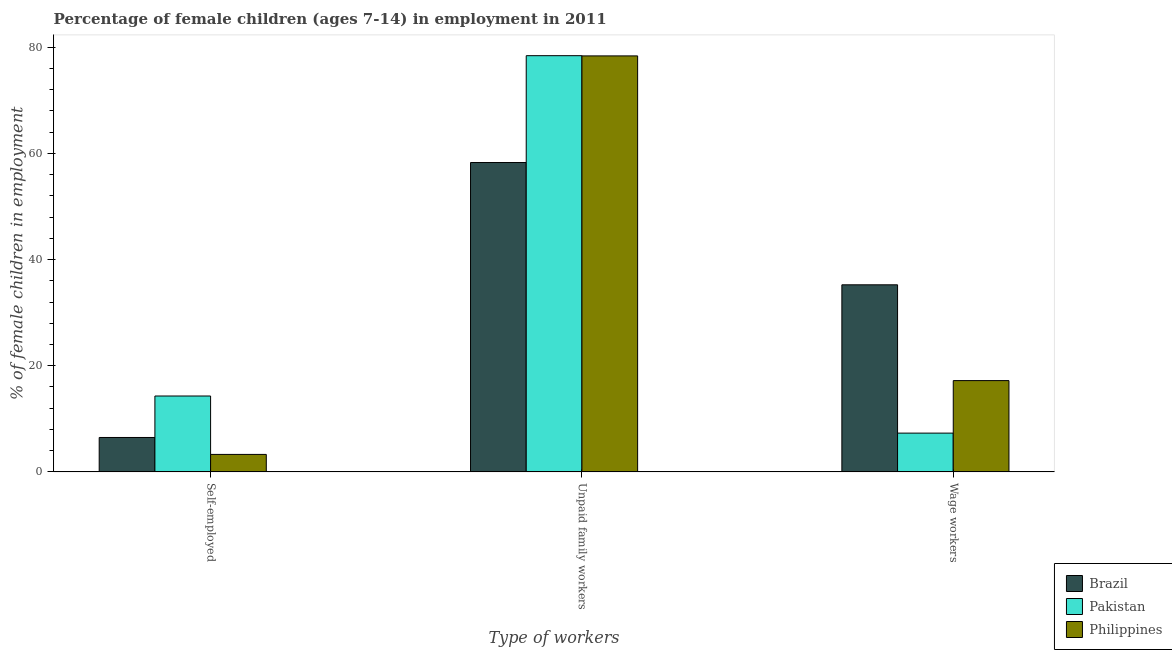How many different coloured bars are there?
Keep it short and to the point. 3. Are the number of bars per tick equal to the number of legend labels?
Your answer should be very brief. Yes. How many bars are there on the 3rd tick from the left?
Your response must be concise. 3. How many bars are there on the 1st tick from the right?
Offer a very short reply. 3. What is the label of the 2nd group of bars from the left?
Your response must be concise. Unpaid family workers. What is the percentage of children employed as wage workers in Brazil?
Keep it short and to the point. 35.24. Across all countries, what is the maximum percentage of children employed as wage workers?
Provide a succinct answer. 35.24. Across all countries, what is the minimum percentage of children employed as unpaid family workers?
Give a very brief answer. 58.27. What is the total percentage of self employed children in the graph?
Your response must be concise. 24.09. What is the difference between the percentage of children employed as unpaid family workers in Philippines and that in Pakistan?
Provide a short and direct response. -0.04. What is the difference between the percentage of self employed children in Pakistan and the percentage of children employed as wage workers in Brazil?
Your response must be concise. -20.94. What is the average percentage of children employed as unpaid family workers per country?
Make the answer very short. 71.67. What is the difference between the percentage of self employed children and percentage of children employed as unpaid family workers in Pakistan?
Offer a very short reply. -64.09. What is the ratio of the percentage of children employed as unpaid family workers in Pakistan to that in Philippines?
Your response must be concise. 1. Is the percentage of self employed children in Philippines less than that in Pakistan?
Ensure brevity in your answer.  Yes. Is the difference between the percentage of self employed children in Pakistan and Brazil greater than the difference between the percentage of children employed as wage workers in Pakistan and Brazil?
Your answer should be very brief. Yes. What is the difference between the highest and the second highest percentage of children employed as unpaid family workers?
Offer a very short reply. 0.04. What is the difference between the highest and the lowest percentage of children employed as unpaid family workers?
Provide a short and direct response. 20.12. Is the sum of the percentage of children employed as wage workers in Pakistan and Brazil greater than the maximum percentage of children employed as unpaid family workers across all countries?
Give a very brief answer. No. What does the 3rd bar from the left in Wage workers represents?
Your answer should be very brief. Philippines. Is it the case that in every country, the sum of the percentage of self employed children and percentage of children employed as unpaid family workers is greater than the percentage of children employed as wage workers?
Keep it short and to the point. Yes. What is the difference between two consecutive major ticks on the Y-axis?
Offer a very short reply. 20. Does the graph contain any zero values?
Ensure brevity in your answer.  No. Does the graph contain grids?
Give a very brief answer. No. Where does the legend appear in the graph?
Your answer should be very brief. Bottom right. How many legend labels are there?
Your response must be concise. 3. How are the legend labels stacked?
Your response must be concise. Vertical. What is the title of the graph?
Your answer should be compact. Percentage of female children (ages 7-14) in employment in 2011. Does "Lesotho" appear as one of the legend labels in the graph?
Offer a very short reply. No. What is the label or title of the X-axis?
Make the answer very short. Type of workers. What is the label or title of the Y-axis?
Offer a very short reply. % of female children in employment. What is the % of female children in employment of Brazil in Self-employed?
Your answer should be very brief. 6.49. What is the % of female children in employment of Philippines in Self-employed?
Your answer should be compact. 3.3. What is the % of female children in employment of Brazil in Unpaid family workers?
Offer a very short reply. 58.27. What is the % of female children in employment in Pakistan in Unpaid family workers?
Your answer should be very brief. 78.39. What is the % of female children in employment in Philippines in Unpaid family workers?
Your answer should be compact. 78.35. What is the % of female children in employment of Brazil in Wage workers?
Offer a very short reply. 35.24. What is the % of female children in employment in Pakistan in Wage workers?
Ensure brevity in your answer.  7.31. Across all Type of workers, what is the maximum % of female children in employment in Brazil?
Keep it short and to the point. 58.27. Across all Type of workers, what is the maximum % of female children in employment of Pakistan?
Offer a very short reply. 78.39. Across all Type of workers, what is the maximum % of female children in employment of Philippines?
Provide a succinct answer. 78.35. Across all Type of workers, what is the minimum % of female children in employment in Brazil?
Make the answer very short. 6.49. Across all Type of workers, what is the minimum % of female children in employment of Pakistan?
Provide a succinct answer. 7.31. Across all Type of workers, what is the minimum % of female children in employment in Philippines?
Provide a succinct answer. 3.3. What is the total % of female children in employment in Philippines in the graph?
Your answer should be very brief. 98.85. What is the difference between the % of female children in employment in Brazil in Self-employed and that in Unpaid family workers?
Your response must be concise. -51.78. What is the difference between the % of female children in employment of Pakistan in Self-employed and that in Unpaid family workers?
Your answer should be very brief. -64.09. What is the difference between the % of female children in employment in Philippines in Self-employed and that in Unpaid family workers?
Make the answer very short. -75.05. What is the difference between the % of female children in employment of Brazil in Self-employed and that in Wage workers?
Provide a short and direct response. -28.75. What is the difference between the % of female children in employment of Pakistan in Self-employed and that in Wage workers?
Give a very brief answer. 6.99. What is the difference between the % of female children in employment in Philippines in Self-employed and that in Wage workers?
Ensure brevity in your answer.  -13.9. What is the difference between the % of female children in employment of Brazil in Unpaid family workers and that in Wage workers?
Provide a succinct answer. 23.03. What is the difference between the % of female children in employment in Pakistan in Unpaid family workers and that in Wage workers?
Provide a succinct answer. 71.08. What is the difference between the % of female children in employment in Philippines in Unpaid family workers and that in Wage workers?
Your response must be concise. 61.15. What is the difference between the % of female children in employment of Brazil in Self-employed and the % of female children in employment of Pakistan in Unpaid family workers?
Keep it short and to the point. -71.9. What is the difference between the % of female children in employment in Brazil in Self-employed and the % of female children in employment in Philippines in Unpaid family workers?
Keep it short and to the point. -71.86. What is the difference between the % of female children in employment in Pakistan in Self-employed and the % of female children in employment in Philippines in Unpaid family workers?
Keep it short and to the point. -64.05. What is the difference between the % of female children in employment of Brazil in Self-employed and the % of female children in employment of Pakistan in Wage workers?
Your answer should be compact. -0.82. What is the difference between the % of female children in employment of Brazil in Self-employed and the % of female children in employment of Philippines in Wage workers?
Keep it short and to the point. -10.71. What is the difference between the % of female children in employment in Brazil in Unpaid family workers and the % of female children in employment in Pakistan in Wage workers?
Your answer should be compact. 50.96. What is the difference between the % of female children in employment of Brazil in Unpaid family workers and the % of female children in employment of Philippines in Wage workers?
Make the answer very short. 41.07. What is the difference between the % of female children in employment of Pakistan in Unpaid family workers and the % of female children in employment of Philippines in Wage workers?
Offer a very short reply. 61.19. What is the average % of female children in employment in Brazil per Type of workers?
Keep it short and to the point. 33.33. What is the average % of female children in employment of Pakistan per Type of workers?
Ensure brevity in your answer.  33.33. What is the average % of female children in employment in Philippines per Type of workers?
Keep it short and to the point. 32.95. What is the difference between the % of female children in employment of Brazil and % of female children in employment of Pakistan in Self-employed?
Your answer should be very brief. -7.81. What is the difference between the % of female children in employment of Brazil and % of female children in employment of Philippines in Self-employed?
Your response must be concise. 3.19. What is the difference between the % of female children in employment of Pakistan and % of female children in employment of Philippines in Self-employed?
Give a very brief answer. 11. What is the difference between the % of female children in employment of Brazil and % of female children in employment of Pakistan in Unpaid family workers?
Offer a terse response. -20.12. What is the difference between the % of female children in employment of Brazil and % of female children in employment of Philippines in Unpaid family workers?
Your response must be concise. -20.08. What is the difference between the % of female children in employment in Pakistan and % of female children in employment in Philippines in Unpaid family workers?
Provide a succinct answer. 0.04. What is the difference between the % of female children in employment in Brazil and % of female children in employment in Pakistan in Wage workers?
Provide a succinct answer. 27.93. What is the difference between the % of female children in employment of Brazil and % of female children in employment of Philippines in Wage workers?
Offer a very short reply. 18.04. What is the difference between the % of female children in employment of Pakistan and % of female children in employment of Philippines in Wage workers?
Offer a very short reply. -9.89. What is the ratio of the % of female children in employment in Brazil in Self-employed to that in Unpaid family workers?
Your answer should be compact. 0.11. What is the ratio of the % of female children in employment of Pakistan in Self-employed to that in Unpaid family workers?
Provide a succinct answer. 0.18. What is the ratio of the % of female children in employment in Philippines in Self-employed to that in Unpaid family workers?
Make the answer very short. 0.04. What is the ratio of the % of female children in employment in Brazil in Self-employed to that in Wage workers?
Your answer should be very brief. 0.18. What is the ratio of the % of female children in employment in Pakistan in Self-employed to that in Wage workers?
Provide a succinct answer. 1.96. What is the ratio of the % of female children in employment in Philippines in Self-employed to that in Wage workers?
Keep it short and to the point. 0.19. What is the ratio of the % of female children in employment in Brazil in Unpaid family workers to that in Wage workers?
Make the answer very short. 1.65. What is the ratio of the % of female children in employment in Pakistan in Unpaid family workers to that in Wage workers?
Keep it short and to the point. 10.72. What is the ratio of the % of female children in employment of Philippines in Unpaid family workers to that in Wage workers?
Ensure brevity in your answer.  4.56. What is the difference between the highest and the second highest % of female children in employment in Brazil?
Provide a short and direct response. 23.03. What is the difference between the highest and the second highest % of female children in employment of Pakistan?
Ensure brevity in your answer.  64.09. What is the difference between the highest and the second highest % of female children in employment of Philippines?
Provide a short and direct response. 61.15. What is the difference between the highest and the lowest % of female children in employment in Brazil?
Keep it short and to the point. 51.78. What is the difference between the highest and the lowest % of female children in employment in Pakistan?
Offer a very short reply. 71.08. What is the difference between the highest and the lowest % of female children in employment in Philippines?
Your answer should be compact. 75.05. 